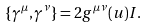Convert formula to latex. <formula><loc_0><loc_0><loc_500><loc_500>\{ \gamma ^ { \mu } , \gamma ^ { \nu } \} = 2 g ^ { \mu \nu } ( u ) I .</formula> 